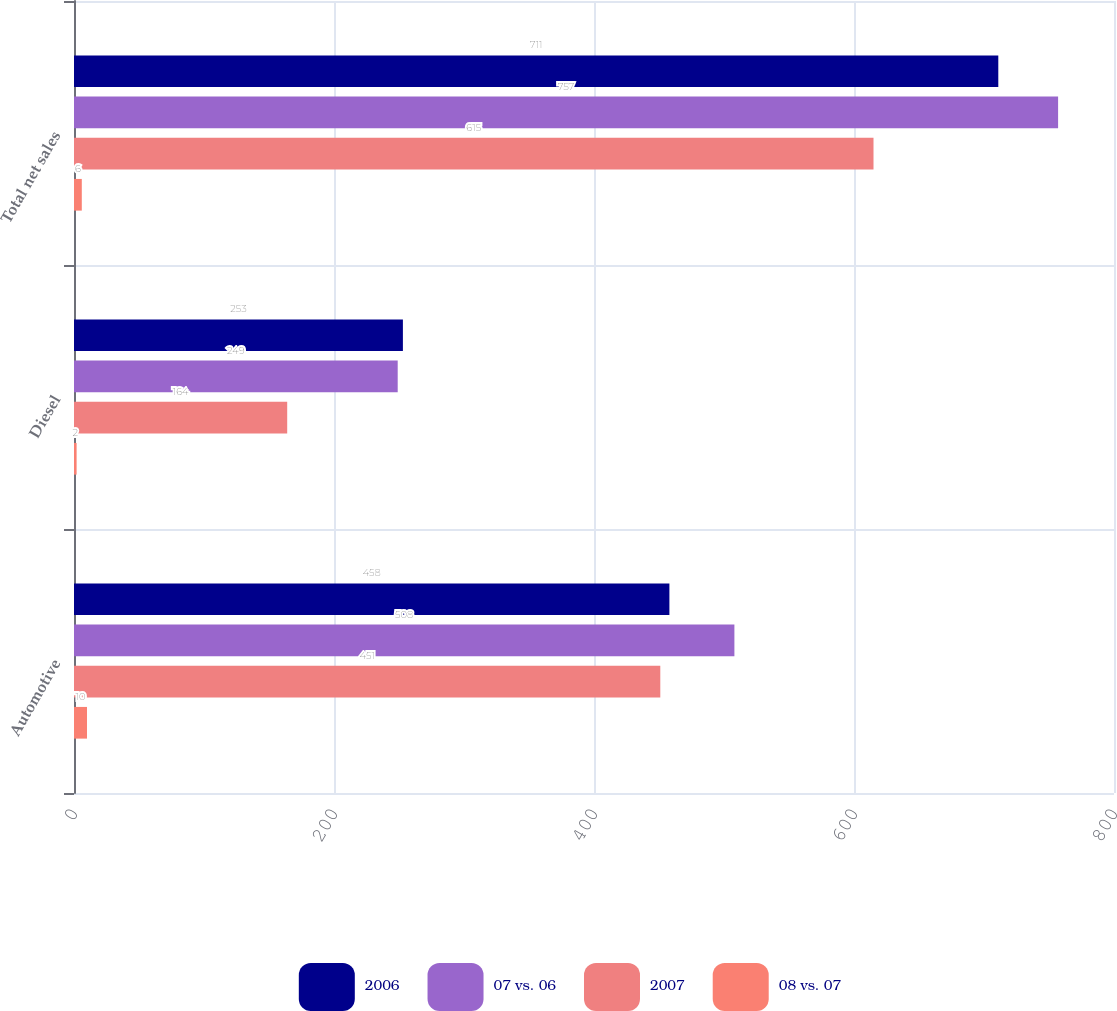Convert chart to OTSL. <chart><loc_0><loc_0><loc_500><loc_500><stacked_bar_chart><ecel><fcel>Automotive<fcel>Diesel<fcel>Total net sales<nl><fcel>2006<fcel>458<fcel>253<fcel>711<nl><fcel>07 vs. 06<fcel>508<fcel>249<fcel>757<nl><fcel>2007<fcel>451<fcel>164<fcel>615<nl><fcel>08 vs. 07<fcel>10<fcel>2<fcel>6<nl></chart> 